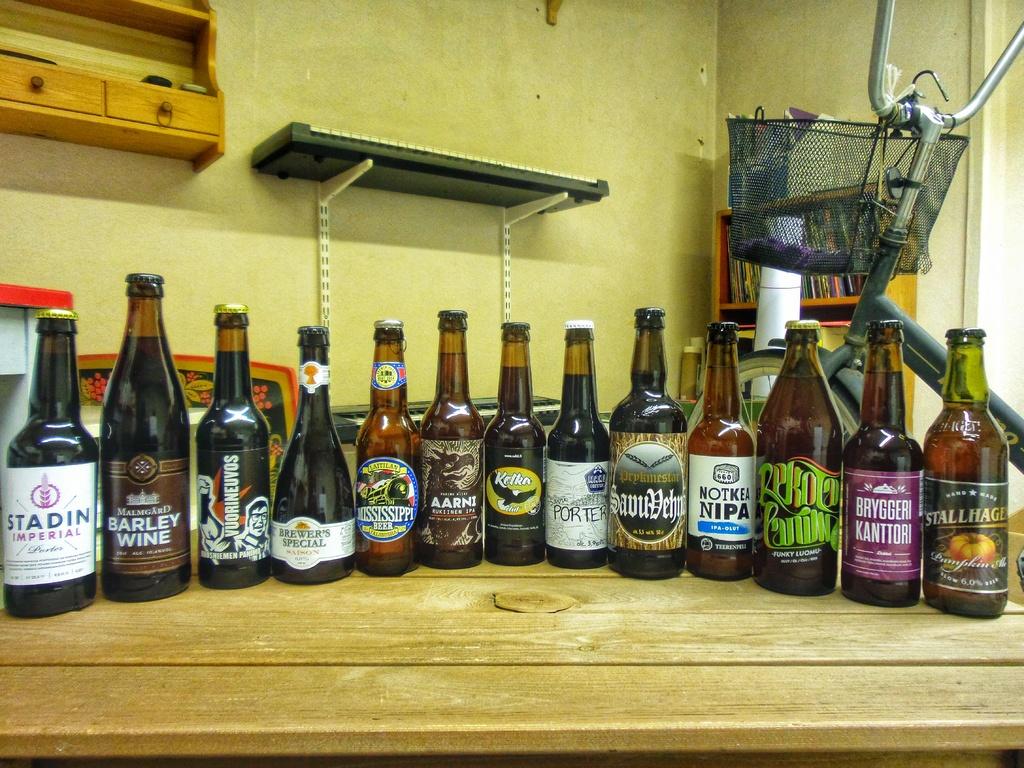What is the name of the first beer from the left?
Your response must be concise. Stadin. What is the name of the beer on the far right?
Make the answer very short. Stallhage. 